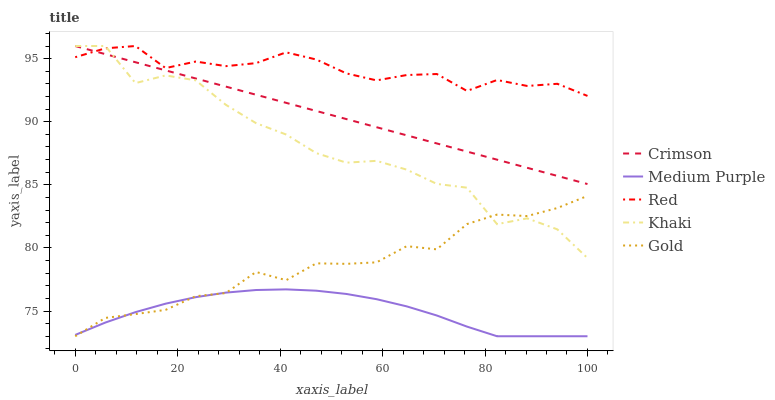Does Medium Purple have the minimum area under the curve?
Answer yes or no. Yes. Does Red have the maximum area under the curve?
Answer yes or no. Yes. Does Khaki have the minimum area under the curve?
Answer yes or no. No. Does Khaki have the maximum area under the curve?
Answer yes or no. No. Is Crimson the smoothest?
Answer yes or no. Yes. Is Khaki the roughest?
Answer yes or no. Yes. Is Medium Purple the smoothest?
Answer yes or no. No. Is Medium Purple the roughest?
Answer yes or no. No. Does Medium Purple have the lowest value?
Answer yes or no. Yes. Does Khaki have the lowest value?
Answer yes or no. No. Does Red have the highest value?
Answer yes or no. Yes. Does Medium Purple have the highest value?
Answer yes or no. No. Is Gold less than Red?
Answer yes or no. Yes. Is Crimson greater than Medium Purple?
Answer yes or no. Yes. Does Khaki intersect Red?
Answer yes or no. Yes. Is Khaki less than Red?
Answer yes or no. No. Is Khaki greater than Red?
Answer yes or no. No. Does Gold intersect Red?
Answer yes or no. No. 